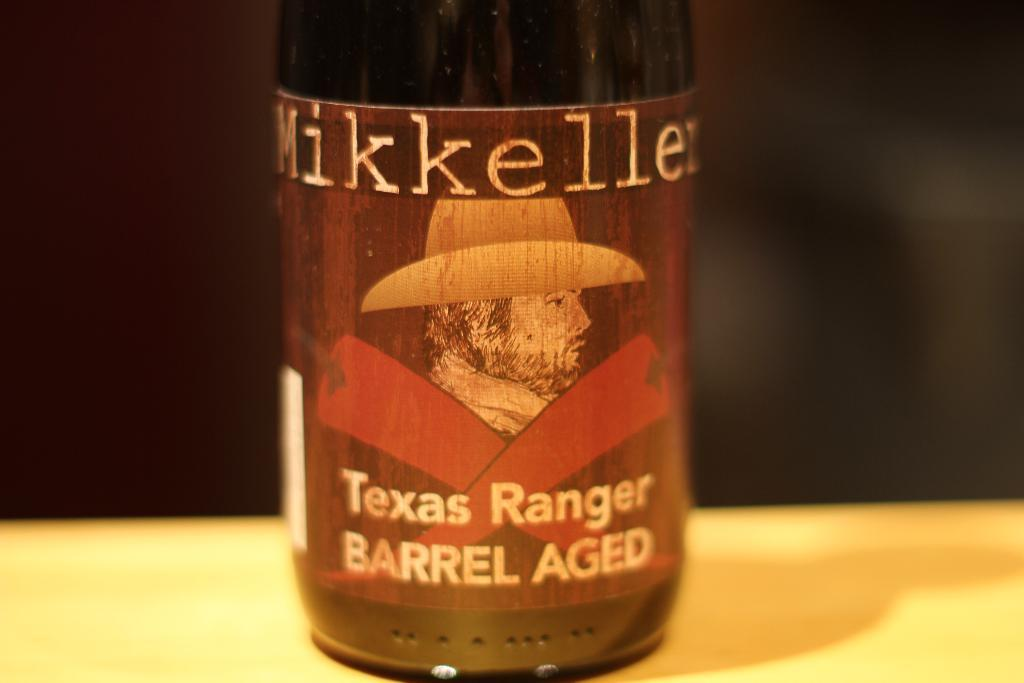Provide a one-sentence caption for the provided image. A bottle of Mikkeller Texas Ranger Barrel Aged alcohol. 